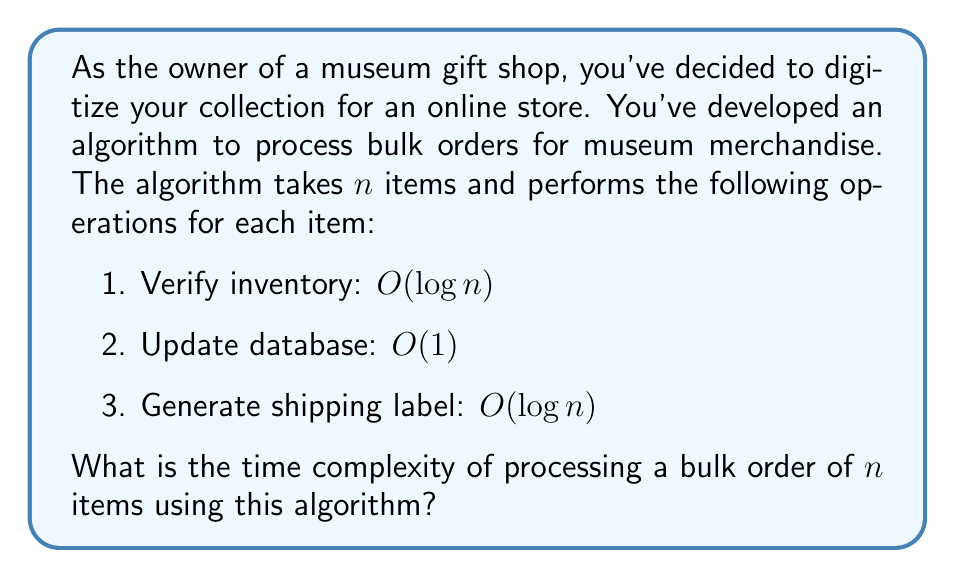Solve this math problem. To determine the time complexity of the bulk order processing algorithm, we need to analyze the operations performed for each item and how they scale with the input size $n$.

1. For each item in the order (total of $n$ items):
   a. Verify inventory: $O(\log n)$
   b. Update database: $O(1)$
   c. Generate shipping label: $O(\log n)$

2. The total time for processing one item is:
   $O(\log n) + O(1) + O(\log n) = O(\log n)$

3. Since we perform these operations for each of the $n$ items, we multiply the time complexity by $n$:
   $n \cdot O(\log n) = O(n \log n)$

The dominant term in this case is $O(n \log n)$, which represents the overall time complexity of the algorithm.

This time complexity suggests that the algorithm's performance will increase slightly more than linearly as the number of items in the bulk order increases. It's more efficient than a quadratic algorithm ($O(n^2)$) but less efficient than a purely linear algorithm ($O(n)$).
Answer: The time complexity of processing a bulk order of $n$ items using this algorithm is $O(n \log n)$. 